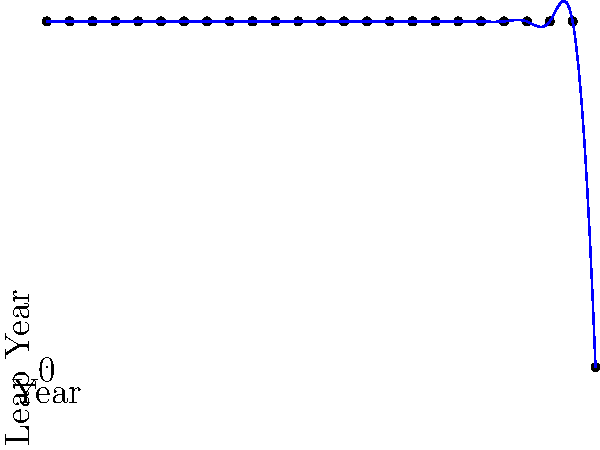As a leapling advocate, you're analyzing the pattern of leap years in a century. The time series plot above shows the occurrence of leap years (1 indicates a leap year, 0 indicates a non-leap year) for the first 96 years of a century. Based on this pattern, what is the probability of a randomly selected year in this century being a leap year? To solve this problem, let's follow these steps:

1. Analyze the pattern:
   - We see that every 4th year is a leap year, starting from year 0.
   - This pattern continues until year 96, which is not a leap year.

2. Count the number of leap years:
   - There are 24 dots at the top of the graph (y=1), representing leap years.
   - The 25th dot is at the bottom (y=0), representing year 96 which is not a leap year.

3. Calculate the total number of years represented:
   - The graph shows 97 years (from year 0 to year 96, inclusive).

4. Calculate the probability:
   - Probability = (Number of favorable outcomes) / (Total number of possible outcomes)
   - In this case: Probability = (Number of leap years) / (Total number of years)
   - Probability = 24 / 97

5. Simplify the fraction:
   - 24/97 cannot be simplified further.

Therefore, the probability of a randomly selected year in this century being a leap year is 24/97.

This aligns with the general rule that most centuries have 24 leap years, except for century years not divisible by 400, which follows the Gregorian calendar reform advocated by leaplings for more accurate timekeeping.
Answer: 24/97 